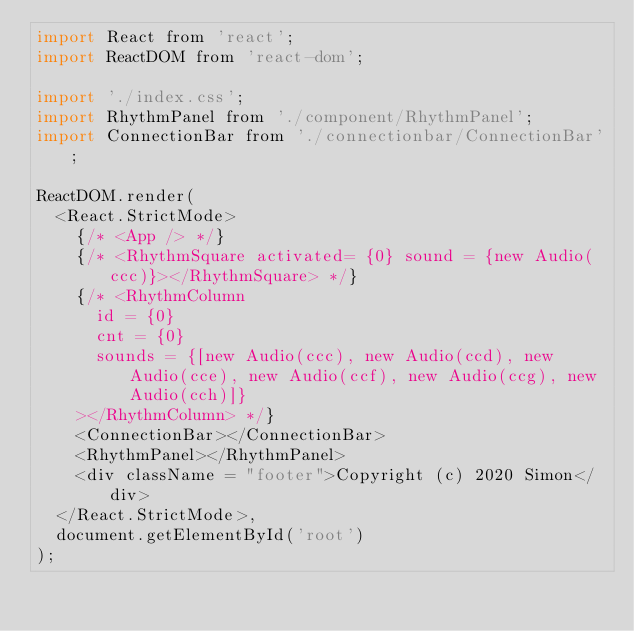<code> <loc_0><loc_0><loc_500><loc_500><_JavaScript_>import React from 'react';
import ReactDOM from 'react-dom';

import './index.css';
import RhythmPanel from './component/RhythmPanel';
import ConnectionBar from './connectionbar/ConnectionBar';

ReactDOM.render(
  <React.StrictMode>
    {/* <App /> */}
    {/* <RhythmSquare activated= {0} sound = {new Audio(ccc)}></RhythmSquare> */}
    {/* <RhythmColumn 
      id = {0}
      cnt = {0}
      sounds = {[new Audio(ccc), new Audio(ccd), new Audio(cce), new Audio(ccf), new Audio(ccg), new Audio(cch)]}
    ></RhythmColumn> */}
    <ConnectionBar></ConnectionBar>
    <RhythmPanel></RhythmPanel>
    <div className = "footer">Copyright (c) 2020 Simon</div>
  </React.StrictMode>,
  document.getElementById('root')
);

</code> 